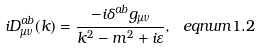Convert formula to latex. <formula><loc_0><loc_0><loc_500><loc_500>i D _ { \mu \nu } ^ { a b } ( k ) = \frac { - i \delta ^ { a b } g _ { \mu \nu } } { k ^ { 2 } - m ^ { 2 } + i \varepsilon } , \ e q n u m { 1 . 2 }</formula> 